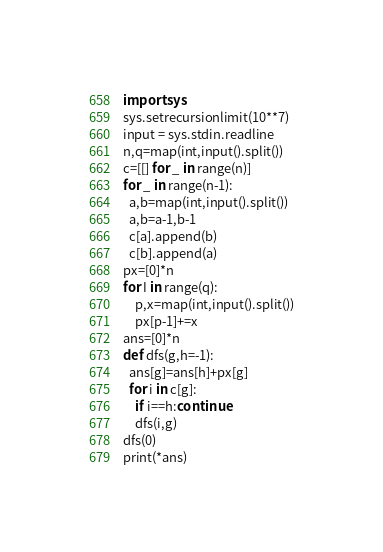Convert code to text. <code><loc_0><loc_0><loc_500><loc_500><_Python_>import sys
sys.setrecursionlimit(10**7)
input = sys.stdin.readline
n,q=map(int,input().split())
c=[[] for _ in range(n)]
for _ in range(n-1):
  a,b=map(int,input().split())
  a,b=a-1,b-1
  c[a].append(b)
  c[b].append(a)
px=[0]*n
for I in range(q):
    p,x=map(int,input().split())
    px[p-1]+=x 
ans=[0]*n
def dfs(g,h=-1):
  ans[g]=ans[h]+px[g]
  for i in c[g]:
    if i==h:continue
    dfs(i,g)
dfs(0)
print(*ans)
</code> 